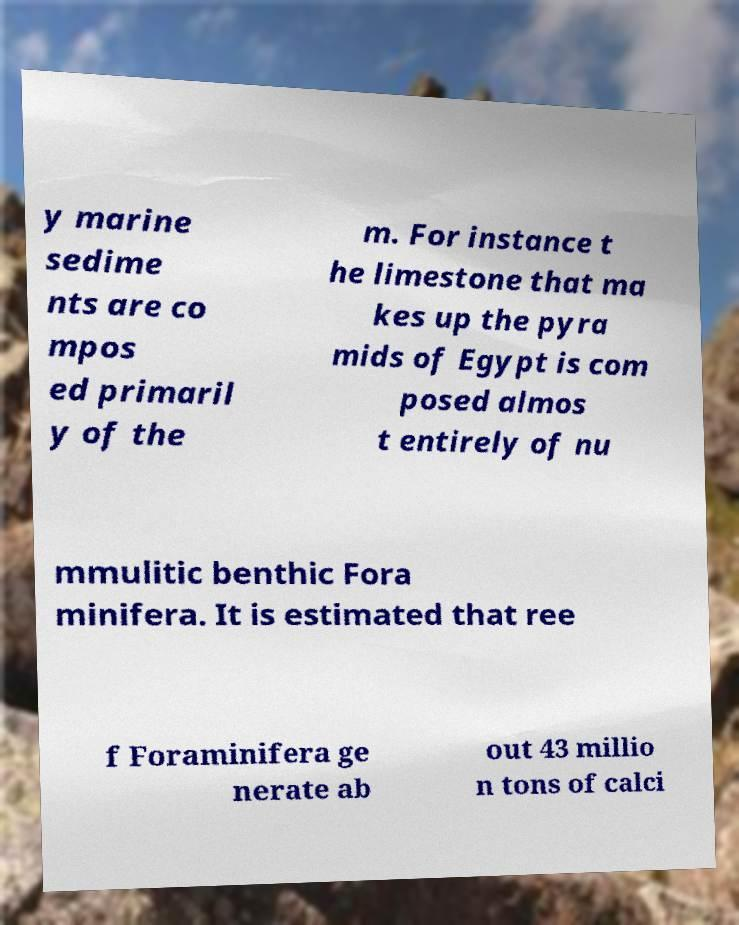I need the written content from this picture converted into text. Can you do that? y marine sedime nts are co mpos ed primaril y of the m. For instance t he limestone that ma kes up the pyra mids of Egypt is com posed almos t entirely of nu mmulitic benthic Fora minifera. It is estimated that ree f Foraminifera ge nerate ab out 43 millio n tons of calci 